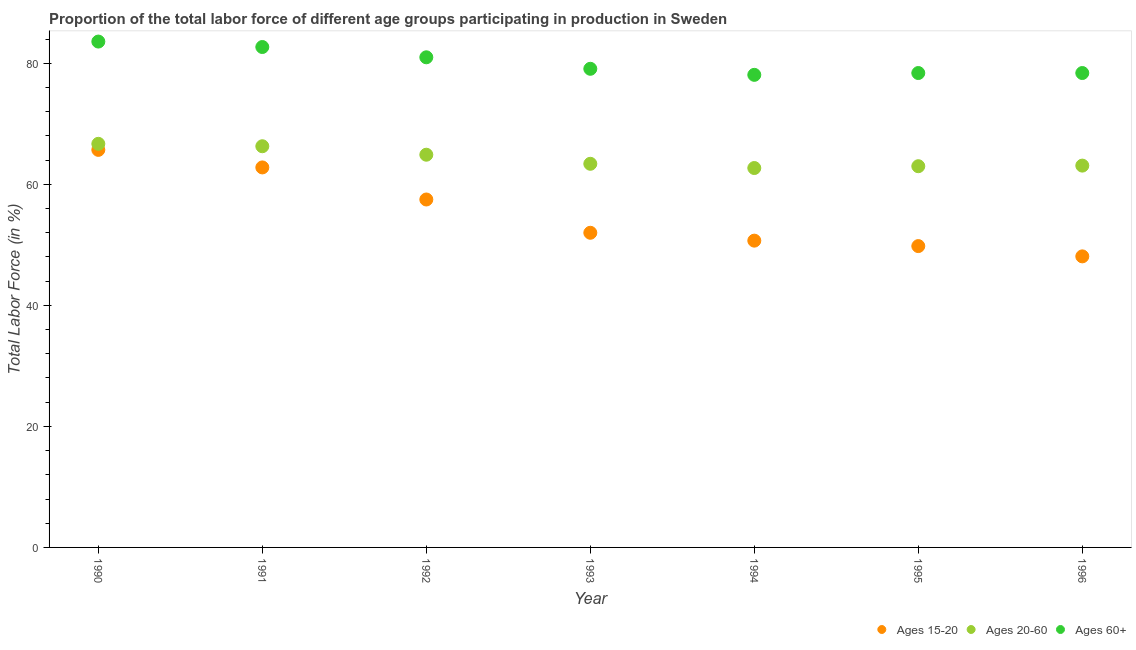What is the percentage of labor force above age 60 in 1992?
Make the answer very short. 81. Across all years, what is the maximum percentage of labor force above age 60?
Provide a succinct answer. 83.6. Across all years, what is the minimum percentage of labor force above age 60?
Offer a very short reply. 78.1. In which year was the percentage of labor force above age 60 maximum?
Provide a short and direct response. 1990. What is the total percentage of labor force within the age group 20-60 in the graph?
Make the answer very short. 450.1. What is the difference between the percentage of labor force within the age group 20-60 in 1993 and that in 1995?
Make the answer very short. 0.4. What is the difference between the percentage of labor force above age 60 in 1996 and the percentage of labor force within the age group 15-20 in 1992?
Your answer should be compact. 20.9. What is the average percentage of labor force within the age group 15-20 per year?
Ensure brevity in your answer.  55.23. In the year 1992, what is the difference between the percentage of labor force above age 60 and percentage of labor force within the age group 15-20?
Ensure brevity in your answer.  23.5. In how many years, is the percentage of labor force within the age group 15-20 greater than 16 %?
Provide a short and direct response. 7. What is the ratio of the percentage of labor force above age 60 in 1991 to that in 1995?
Offer a terse response. 1.05. Is the percentage of labor force within the age group 15-20 in 1991 less than that in 1993?
Your response must be concise. No. What is the difference between the highest and the second highest percentage of labor force within the age group 20-60?
Provide a short and direct response. 0.4. What is the difference between the highest and the lowest percentage of labor force within the age group 20-60?
Make the answer very short. 4. In how many years, is the percentage of labor force above age 60 greater than the average percentage of labor force above age 60 taken over all years?
Give a very brief answer. 3. Is the sum of the percentage of labor force within the age group 15-20 in 1991 and 1994 greater than the maximum percentage of labor force within the age group 20-60 across all years?
Offer a terse response. Yes. Is it the case that in every year, the sum of the percentage of labor force within the age group 15-20 and percentage of labor force within the age group 20-60 is greater than the percentage of labor force above age 60?
Your response must be concise. Yes. Does the percentage of labor force within the age group 20-60 monotonically increase over the years?
Your answer should be very brief. No. Is the percentage of labor force above age 60 strictly greater than the percentage of labor force within the age group 15-20 over the years?
Offer a terse response. Yes. Does the graph contain any zero values?
Provide a short and direct response. No. Does the graph contain grids?
Your response must be concise. No. Where does the legend appear in the graph?
Keep it short and to the point. Bottom right. How many legend labels are there?
Your answer should be compact. 3. How are the legend labels stacked?
Your answer should be compact. Horizontal. What is the title of the graph?
Offer a very short reply. Proportion of the total labor force of different age groups participating in production in Sweden. Does "Infant(female)" appear as one of the legend labels in the graph?
Your answer should be compact. No. What is the Total Labor Force (in %) of Ages 15-20 in 1990?
Offer a terse response. 65.7. What is the Total Labor Force (in %) of Ages 20-60 in 1990?
Your answer should be very brief. 66.7. What is the Total Labor Force (in %) of Ages 60+ in 1990?
Provide a short and direct response. 83.6. What is the Total Labor Force (in %) in Ages 15-20 in 1991?
Your answer should be very brief. 62.8. What is the Total Labor Force (in %) in Ages 20-60 in 1991?
Offer a very short reply. 66.3. What is the Total Labor Force (in %) of Ages 60+ in 1991?
Provide a short and direct response. 82.7. What is the Total Labor Force (in %) of Ages 15-20 in 1992?
Your response must be concise. 57.5. What is the Total Labor Force (in %) in Ages 20-60 in 1992?
Your answer should be very brief. 64.9. What is the Total Labor Force (in %) of Ages 15-20 in 1993?
Ensure brevity in your answer.  52. What is the Total Labor Force (in %) in Ages 20-60 in 1993?
Ensure brevity in your answer.  63.4. What is the Total Labor Force (in %) in Ages 60+ in 1993?
Your answer should be compact. 79.1. What is the Total Labor Force (in %) in Ages 15-20 in 1994?
Offer a very short reply. 50.7. What is the Total Labor Force (in %) of Ages 20-60 in 1994?
Your answer should be compact. 62.7. What is the Total Labor Force (in %) of Ages 60+ in 1994?
Your response must be concise. 78.1. What is the Total Labor Force (in %) in Ages 15-20 in 1995?
Keep it short and to the point. 49.8. What is the Total Labor Force (in %) in Ages 60+ in 1995?
Ensure brevity in your answer.  78.4. What is the Total Labor Force (in %) in Ages 15-20 in 1996?
Make the answer very short. 48.1. What is the Total Labor Force (in %) of Ages 20-60 in 1996?
Your response must be concise. 63.1. What is the Total Labor Force (in %) in Ages 60+ in 1996?
Keep it short and to the point. 78.4. Across all years, what is the maximum Total Labor Force (in %) in Ages 15-20?
Make the answer very short. 65.7. Across all years, what is the maximum Total Labor Force (in %) in Ages 20-60?
Make the answer very short. 66.7. Across all years, what is the maximum Total Labor Force (in %) in Ages 60+?
Offer a very short reply. 83.6. Across all years, what is the minimum Total Labor Force (in %) in Ages 15-20?
Ensure brevity in your answer.  48.1. Across all years, what is the minimum Total Labor Force (in %) in Ages 20-60?
Your answer should be very brief. 62.7. Across all years, what is the minimum Total Labor Force (in %) in Ages 60+?
Offer a terse response. 78.1. What is the total Total Labor Force (in %) in Ages 15-20 in the graph?
Provide a succinct answer. 386.6. What is the total Total Labor Force (in %) of Ages 20-60 in the graph?
Give a very brief answer. 450.1. What is the total Total Labor Force (in %) in Ages 60+ in the graph?
Your answer should be compact. 561.3. What is the difference between the Total Labor Force (in %) of Ages 15-20 in 1990 and that in 1991?
Offer a terse response. 2.9. What is the difference between the Total Labor Force (in %) of Ages 20-60 in 1990 and that in 1991?
Provide a succinct answer. 0.4. What is the difference between the Total Labor Force (in %) of Ages 20-60 in 1990 and that in 1992?
Your answer should be compact. 1.8. What is the difference between the Total Labor Force (in %) of Ages 60+ in 1990 and that in 1994?
Provide a short and direct response. 5.5. What is the difference between the Total Labor Force (in %) of Ages 15-20 in 1990 and that in 1995?
Ensure brevity in your answer.  15.9. What is the difference between the Total Labor Force (in %) of Ages 60+ in 1990 and that in 1995?
Offer a very short reply. 5.2. What is the difference between the Total Labor Force (in %) in Ages 60+ in 1990 and that in 1996?
Your answer should be compact. 5.2. What is the difference between the Total Labor Force (in %) in Ages 15-20 in 1991 and that in 1992?
Keep it short and to the point. 5.3. What is the difference between the Total Labor Force (in %) in Ages 20-60 in 1991 and that in 1992?
Offer a terse response. 1.4. What is the difference between the Total Labor Force (in %) in Ages 60+ in 1991 and that in 1992?
Provide a short and direct response. 1.7. What is the difference between the Total Labor Force (in %) of Ages 20-60 in 1991 and that in 1993?
Your response must be concise. 2.9. What is the difference between the Total Labor Force (in %) in Ages 15-20 in 1991 and that in 1994?
Your answer should be very brief. 12.1. What is the difference between the Total Labor Force (in %) of Ages 15-20 in 1991 and that in 1995?
Make the answer very short. 13. What is the difference between the Total Labor Force (in %) in Ages 15-20 in 1991 and that in 1996?
Your answer should be compact. 14.7. What is the difference between the Total Labor Force (in %) in Ages 20-60 in 1991 and that in 1996?
Keep it short and to the point. 3.2. What is the difference between the Total Labor Force (in %) in Ages 60+ in 1991 and that in 1996?
Your answer should be very brief. 4.3. What is the difference between the Total Labor Force (in %) of Ages 15-20 in 1992 and that in 1993?
Provide a succinct answer. 5.5. What is the difference between the Total Labor Force (in %) in Ages 20-60 in 1992 and that in 1993?
Your response must be concise. 1.5. What is the difference between the Total Labor Force (in %) in Ages 60+ in 1992 and that in 1993?
Provide a succinct answer. 1.9. What is the difference between the Total Labor Force (in %) of Ages 15-20 in 1992 and that in 1994?
Offer a terse response. 6.8. What is the difference between the Total Labor Force (in %) of Ages 20-60 in 1992 and that in 1994?
Provide a succinct answer. 2.2. What is the difference between the Total Labor Force (in %) of Ages 20-60 in 1992 and that in 1995?
Keep it short and to the point. 1.9. What is the difference between the Total Labor Force (in %) of Ages 60+ in 1992 and that in 1996?
Your answer should be very brief. 2.6. What is the difference between the Total Labor Force (in %) in Ages 20-60 in 1993 and that in 1994?
Offer a very short reply. 0.7. What is the difference between the Total Labor Force (in %) in Ages 20-60 in 1993 and that in 1995?
Offer a terse response. 0.4. What is the difference between the Total Labor Force (in %) in Ages 60+ in 1993 and that in 1996?
Offer a terse response. 0.7. What is the difference between the Total Labor Force (in %) in Ages 15-20 in 1995 and that in 1996?
Your response must be concise. 1.7. What is the difference between the Total Labor Force (in %) of Ages 15-20 in 1990 and the Total Labor Force (in %) of Ages 60+ in 1991?
Make the answer very short. -17. What is the difference between the Total Labor Force (in %) in Ages 20-60 in 1990 and the Total Labor Force (in %) in Ages 60+ in 1991?
Ensure brevity in your answer.  -16. What is the difference between the Total Labor Force (in %) in Ages 15-20 in 1990 and the Total Labor Force (in %) in Ages 60+ in 1992?
Keep it short and to the point. -15.3. What is the difference between the Total Labor Force (in %) of Ages 20-60 in 1990 and the Total Labor Force (in %) of Ages 60+ in 1992?
Ensure brevity in your answer.  -14.3. What is the difference between the Total Labor Force (in %) of Ages 20-60 in 1990 and the Total Labor Force (in %) of Ages 60+ in 1993?
Provide a short and direct response. -12.4. What is the difference between the Total Labor Force (in %) of Ages 15-20 in 1990 and the Total Labor Force (in %) of Ages 20-60 in 1994?
Offer a terse response. 3. What is the difference between the Total Labor Force (in %) in Ages 15-20 in 1990 and the Total Labor Force (in %) in Ages 20-60 in 1995?
Make the answer very short. 2.7. What is the difference between the Total Labor Force (in %) of Ages 15-20 in 1990 and the Total Labor Force (in %) of Ages 60+ in 1995?
Provide a succinct answer. -12.7. What is the difference between the Total Labor Force (in %) of Ages 20-60 in 1990 and the Total Labor Force (in %) of Ages 60+ in 1995?
Your answer should be very brief. -11.7. What is the difference between the Total Labor Force (in %) in Ages 15-20 in 1990 and the Total Labor Force (in %) in Ages 20-60 in 1996?
Provide a succinct answer. 2.6. What is the difference between the Total Labor Force (in %) in Ages 20-60 in 1990 and the Total Labor Force (in %) in Ages 60+ in 1996?
Offer a terse response. -11.7. What is the difference between the Total Labor Force (in %) of Ages 15-20 in 1991 and the Total Labor Force (in %) of Ages 60+ in 1992?
Your response must be concise. -18.2. What is the difference between the Total Labor Force (in %) in Ages 20-60 in 1991 and the Total Labor Force (in %) in Ages 60+ in 1992?
Your response must be concise. -14.7. What is the difference between the Total Labor Force (in %) in Ages 15-20 in 1991 and the Total Labor Force (in %) in Ages 60+ in 1993?
Make the answer very short. -16.3. What is the difference between the Total Labor Force (in %) of Ages 15-20 in 1991 and the Total Labor Force (in %) of Ages 60+ in 1994?
Keep it short and to the point. -15.3. What is the difference between the Total Labor Force (in %) of Ages 15-20 in 1991 and the Total Labor Force (in %) of Ages 20-60 in 1995?
Provide a succinct answer. -0.2. What is the difference between the Total Labor Force (in %) in Ages 15-20 in 1991 and the Total Labor Force (in %) in Ages 60+ in 1995?
Keep it short and to the point. -15.6. What is the difference between the Total Labor Force (in %) of Ages 15-20 in 1991 and the Total Labor Force (in %) of Ages 60+ in 1996?
Your response must be concise. -15.6. What is the difference between the Total Labor Force (in %) of Ages 20-60 in 1991 and the Total Labor Force (in %) of Ages 60+ in 1996?
Keep it short and to the point. -12.1. What is the difference between the Total Labor Force (in %) in Ages 15-20 in 1992 and the Total Labor Force (in %) in Ages 20-60 in 1993?
Ensure brevity in your answer.  -5.9. What is the difference between the Total Labor Force (in %) of Ages 15-20 in 1992 and the Total Labor Force (in %) of Ages 60+ in 1993?
Your response must be concise. -21.6. What is the difference between the Total Labor Force (in %) in Ages 20-60 in 1992 and the Total Labor Force (in %) in Ages 60+ in 1993?
Keep it short and to the point. -14.2. What is the difference between the Total Labor Force (in %) in Ages 15-20 in 1992 and the Total Labor Force (in %) in Ages 20-60 in 1994?
Ensure brevity in your answer.  -5.2. What is the difference between the Total Labor Force (in %) of Ages 15-20 in 1992 and the Total Labor Force (in %) of Ages 60+ in 1994?
Give a very brief answer. -20.6. What is the difference between the Total Labor Force (in %) in Ages 15-20 in 1992 and the Total Labor Force (in %) in Ages 60+ in 1995?
Give a very brief answer. -20.9. What is the difference between the Total Labor Force (in %) in Ages 15-20 in 1992 and the Total Labor Force (in %) in Ages 20-60 in 1996?
Your response must be concise. -5.6. What is the difference between the Total Labor Force (in %) of Ages 15-20 in 1992 and the Total Labor Force (in %) of Ages 60+ in 1996?
Provide a short and direct response. -20.9. What is the difference between the Total Labor Force (in %) in Ages 15-20 in 1993 and the Total Labor Force (in %) in Ages 20-60 in 1994?
Give a very brief answer. -10.7. What is the difference between the Total Labor Force (in %) of Ages 15-20 in 1993 and the Total Labor Force (in %) of Ages 60+ in 1994?
Provide a succinct answer. -26.1. What is the difference between the Total Labor Force (in %) in Ages 20-60 in 1993 and the Total Labor Force (in %) in Ages 60+ in 1994?
Ensure brevity in your answer.  -14.7. What is the difference between the Total Labor Force (in %) in Ages 15-20 in 1993 and the Total Labor Force (in %) in Ages 20-60 in 1995?
Your response must be concise. -11. What is the difference between the Total Labor Force (in %) in Ages 15-20 in 1993 and the Total Labor Force (in %) in Ages 60+ in 1995?
Provide a short and direct response. -26.4. What is the difference between the Total Labor Force (in %) of Ages 15-20 in 1993 and the Total Labor Force (in %) of Ages 60+ in 1996?
Your response must be concise. -26.4. What is the difference between the Total Labor Force (in %) in Ages 15-20 in 1994 and the Total Labor Force (in %) in Ages 60+ in 1995?
Make the answer very short. -27.7. What is the difference between the Total Labor Force (in %) of Ages 20-60 in 1994 and the Total Labor Force (in %) of Ages 60+ in 1995?
Your answer should be compact. -15.7. What is the difference between the Total Labor Force (in %) in Ages 15-20 in 1994 and the Total Labor Force (in %) in Ages 60+ in 1996?
Provide a succinct answer. -27.7. What is the difference between the Total Labor Force (in %) in Ages 20-60 in 1994 and the Total Labor Force (in %) in Ages 60+ in 1996?
Offer a terse response. -15.7. What is the difference between the Total Labor Force (in %) in Ages 15-20 in 1995 and the Total Labor Force (in %) in Ages 60+ in 1996?
Keep it short and to the point. -28.6. What is the difference between the Total Labor Force (in %) of Ages 20-60 in 1995 and the Total Labor Force (in %) of Ages 60+ in 1996?
Ensure brevity in your answer.  -15.4. What is the average Total Labor Force (in %) of Ages 15-20 per year?
Offer a very short reply. 55.23. What is the average Total Labor Force (in %) in Ages 20-60 per year?
Ensure brevity in your answer.  64.3. What is the average Total Labor Force (in %) of Ages 60+ per year?
Make the answer very short. 80.19. In the year 1990, what is the difference between the Total Labor Force (in %) of Ages 15-20 and Total Labor Force (in %) of Ages 60+?
Offer a very short reply. -17.9. In the year 1990, what is the difference between the Total Labor Force (in %) in Ages 20-60 and Total Labor Force (in %) in Ages 60+?
Your response must be concise. -16.9. In the year 1991, what is the difference between the Total Labor Force (in %) in Ages 15-20 and Total Labor Force (in %) in Ages 20-60?
Your answer should be compact. -3.5. In the year 1991, what is the difference between the Total Labor Force (in %) in Ages 15-20 and Total Labor Force (in %) in Ages 60+?
Ensure brevity in your answer.  -19.9. In the year 1991, what is the difference between the Total Labor Force (in %) in Ages 20-60 and Total Labor Force (in %) in Ages 60+?
Offer a very short reply. -16.4. In the year 1992, what is the difference between the Total Labor Force (in %) in Ages 15-20 and Total Labor Force (in %) in Ages 60+?
Offer a terse response. -23.5. In the year 1992, what is the difference between the Total Labor Force (in %) in Ages 20-60 and Total Labor Force (in %) in Ages 60+?
Give a very brief answer. -16.1. In the year 1993, what is the difference between the Total Labor Force (in %) in Ages 15-20 and Total Labor Force (in %) in Ages 60+?
Keep it short and to the point. -27.1. In the year 1993, what is the difference between the Total Labor Force (in %) of Ages 20-60 and Total Labor Force (in %) of Ages 60+?
Provide a succinct answer. -15.7. In the year 1994, what is the difference between the Total Labor Force (in %) in Ages 15-20 and Total Labor Force (in %) in Ages 20-60?
Provide a succinct answer. -12. In the year 1994, what is the difference between the Total Labor Force (in %) of Ages 15-20 and Total Labor Force (in %) of Ages 60+?
Offer a terse response. -27.4. In the year 1994, what is the difference between the Total Labor Force (in %) in Ages 20-60 and Total Labor Force (in %) in Ages 60+?
Your answer should be very brief. -15.4. In the year 1995, what is the difference between the Total Labor Force (in %) of Ages 15-20 and Total Labor Force (in %) of Ages 20-60?
Keep it short and to the point. -13.2. In the year 1995, what is the difference between the Total Labor Force (in %) in Ages 15-20 and Total Labor Force (in %) in Ages 60+?
Provide a short and direct response. -28.6. In the year 1995, what is the difference between the Total Labor Force (in %) of Ages 20-60 and Total Labor Force (in %) of Ages 60+?
Your answer should be compact. -15.4. In the year 1996, what is the difference between the Total Labor Force (in %) of Ages 15-20 and Total Labor Force (in %) of Ages 20-60?
Provide a short and direct response. -15. In the year 1996, what is the difference between the Total Labor Force (in %) in Ages 15-20 and Total Labor Force (in %) in Ages 60+?
Your answer should be compact. -30.3. In the year 1996, what is the difference between the Total Labor Force (in %) in Ages 20-60 and Total Labor Force (in %) in Ages 60+?
Make the answer very short. -15.3. What is the ratio of the Total Labor Force (in %) of Ages 15-20 in 1990 to that in 1991?
Provide a short and direct response. 1.05. What is the ratio of the Total Labor Force (in %) in Ages 20-60 in 1990 to that in 1991?
Your response must be concise. 1.01. What is the ratio of the Total Labor Force (in %) of Ages 60+ in 1990 to that in 1991?
Offer a terse response. 1.01. What is the ratio of the Total Labor Force (in %) of Ages 15-20 in 1990 to that in 1992?
Provide a succinct answer. 1.14. What is the ratio of the Total Labor Force (in %) of Ages 20-60 in 1990 to that in 1992?
Provide a succinct answer. 1.03. What is the ratio of the Total Labor Force (in %) in Ages 60+ in 1990 to that in 1992?
Provide a short and direct response. 1.03. What is the ratio of the Total Labor Force (in %) of Ages 15-20 in 1990 to that in 1993?
Make the answer very short. 1.26. What is the ratio of the Total Labor Force (in %) of Ages 20-60 in 1990 to that in 1993?
Offer a very short reply. 1.05. What is the ratio of the Total Labor Force (in %) of Ages 60+ in 1990 to that in 1993?
Ensure brevity in your answer.  1.06. What is the ratio of the Total Labor Force (in %) in Ages 15-20 in 1990 to that in 1994?
Offer a terse response. 1.3. What is the ratio of the Total Labor Force (in %) in Ages 20-60 in 1990 to that in 1994?
Make the answer very short. 1.06. What is the ratio of the Total Labor Force (in %) of Ages 60+ in 1990 to that in 1994?
Your response must be concise. 1.07. What is the ratio of the Total Labor Force (in %) in Ages 15-20 in 1990 to that in 1995?
Make the answer very short. 1.32. What is the ratio of the Total Labor Force (in %) in Ages 20-60 in 1990 to that in 1995?
Your answer should be compact. 1.06. What is the ratio of the Total Labor Force (in %) of Ages 60+ in 1990 to that in 1995?
Your answer should be compact. 1.07. What is the ratio of the Total Labor Force (in %) in Ages 15-20 in 1990 to that in 1996?
Your answer should be compact. 1.37. What is the ratio of the Total Labor Force (in %) of Ages 20-60 in 1990 to that in 1996?
Ensure brevity in your answer.  1.06. What is the ratio of the Total Labor Force (in %) in Ages 60+ in 1990 to that in 1996?
Provide a short and direct response. 1.07. What is the ratio of the Total Labor Force (in %) in Ages 15-20 in 1991 to that in 1992?
Make the answer very short. 1.09. What is the ratio of the Total Labor Force (in %) in Ages 20-60 in 1991 to that in 1992?
Provide a succinct answer. 1.02. What is the ratio of the Total Labor Force (in %) in Ages 15-20 in 1991 to that in 1993?
Your response must be concise. 1.21. What is the ratio of the Total Labor Force (in %) in Ages 20-60 in 1991 to that in 1993?
Offer a terse response. 1.05. What is the ratio of the Total Labor Force (in %) in Ages 60+ in 1991 to that in 1993?
Offer a very short reply. 1.05. What is the ratio of the Total Labor Force (in %) in Ages 15-20 in 1991 to that in 1994?
Provide a succinct answer. 1.24. What is the ratio of the Total Labor Force (in %) of Ages 20-60 in 1991 to that in 1994?
Your response must be concise. 1.06. What is the ratio of the Total Labor Force (in %) of Ages 60+ in 1991 to that in 1994?
Make the answer very short. 1.06. What is the ratio of the Total Labor Force (in %) of Ages 15-20 in 1991 to that in 1995?
Offer a terse response. 1.26. What is the ratio of the Total Labor Force (in %) of Ages 20-60 in 1991 to that in 1995?
Give a very brief answer. 1.05. What is the ratio of the Total Labor Force (in %) in Ages 60+ in 1991 to that in 1995?
Provide a succinct answer. 1.05. What is the ratio of the Total Labor Force (in %) in Ages 15-20 in 1991 to that in 1996?
Offer a very short reply. 1.31. What is the ratio of the Total Labor Force (in %) in Ages 20-60 in 1991 to that in 1996?
Ensure brevity in your answer.  1.05. What is the ratio of the Total Labor Force (in %) in Ages 60+ in 1991 to that in 1996?
Offer a terse response. 1.05. What is the ratio of the Total Labor Force (in %) of Ages 15-20 in 1992 to that in 1993?
Offer a terse response. 1.11. What is the ratio of the Total Labor Force (in %) of Ages 20-60 in 1992 to that in 1993?
Provide a short and direct response. 1.02. What is the ratio of the Total Labor Force (in %) of Ages 15-20 in 1992 to that in 1994?
Your response must be concise. 1.13. What is the ratio of the Total Labor Force (in %) in Ages 20-60 in 1992 to that in 1994?
Offer a terse response. 1.04. What is the ratio of the Total Labor Force (in %) in Ages 60+ in 1992 to that in 1994?
Make the answer very short. 1.04. What is the ratio of the Total Labor Force (in %) in Ages 15-20 in 1992 to that in 1995?
Offer a very short reply. 1.15. What is the ratio of the Total Labor Force (in %) of Ages 20-60 in 1992 to that in 1995?
Keep it short and to the point. 1.03. What is the ratio of the Total Labor Force (in %) in Ages 60+ in 1992 to that in 1995?
Keep it short and to the point. 1.03. What is the ratio of the Total Labor Force (in %) of Ages 15-20 in 1992 to that in 1996?
Offer a terse response. 1.2. What is the ratio of the Total Labor Force (in %) of Ages 20-60 in 1992 to that in 1996?
Your response must be concise. 1.03. What is the ratio of the Total Labor Force (in %) of Ages 60+ in 1992 to that in 1996?
Provide a succinct answer. 1.03. What is the ratio of the Total Labor Force (in %) in Ages 15-20 in 1993 to that in 1994?
Give a very brief answer. 1.03. What is the ratio of the Total Labor Force (in %) in Ages 20-60 in 1993 to that in 1994?
Provide a short and direct response. 1.01. What is the ratio of the Total Labor Force (in %) in Ages 60+ in 1993 to that in 1994?
Give a very brief answer. 1.01. What is the ratio of the Total Labor Force (in %) in Ages 15-20 in 1993 to that in 1995?
Provide a succinct answer. 1.04. What is the ratio of the Total Labor Force (in %) in Ages 20-60 in 1993 to that in 1995?
Offer a very short reply. 1.01. What is the ratio of the Total Labor Force (in %) of Ages 60+ in 1993 to that in 1995?
Your response must be concise. 1.01. What is the ratio of the Total Labor Force (in %) of Ages 15-20 in 1993 to that in 1996?
Your answer should be compact. 1.08. What is the ratio of the Total Labor Force (in %) in Ages 20-60 in 1993 to that in 1996?
Provide a succinct answer. 1. What is the ratio of the Total Labor Force (in %) in Ages 60+ in 1993 to that in 1996?
Your answer should be very brief. 1.01. What is the ratio of the Total Labor Force (in %) of Ages 15-20 in 1994 to that in 1995?
Your answer should be very brief. 1.02. What is the ratio of the Total Labor Force (in %) in Ages 60+ in 1994 to that in 1995?
Offer a very short reply. 1. What is the ratio of the Total Labor Force (in %) of Ages 15-20 in 1994 to that in 1996?
Your response must be concise. 1.05. What is the ratio of the Total Labor Force (in %) in Ages 20-60 in 1994 to that in 1996?
Provide a succinct answer. 0.99. What is the ratio of the Total Labor Force (in %) of Ages 60+ in 1994 to that in 1996?
Provide a short and direct response. 1. What is the ratio of the Total Labor Force (in %) in Ages 15-20 in 1995 to that in 1996?
Your answer should be very brief. 1.04. What is the ratio of the Total Labor Force (in %) of Ages 20-60 in 1995 to that in 1996?
Keep it short and to the point. 1. What is the ratio of the Total Labor Force (in %) of Ages 60+ in 1995 to that in 1996?
Keep it short and to the point. 1. What is the difference between the highest and the second highest Total Labor Force (in %) of Ages 20-60?
Offer a terse response. 0.4. What is the difference between the highest and the second highest Total Labor Force (in %) in Ages 60+?
Your answer should be compact. 0.9. What is the difference between the highest and the lowest Total Labor Force (in %) of Ages 15-20?
Provide a short and direct response. 17.6. 